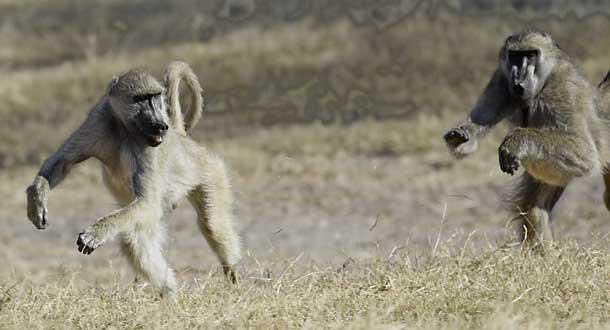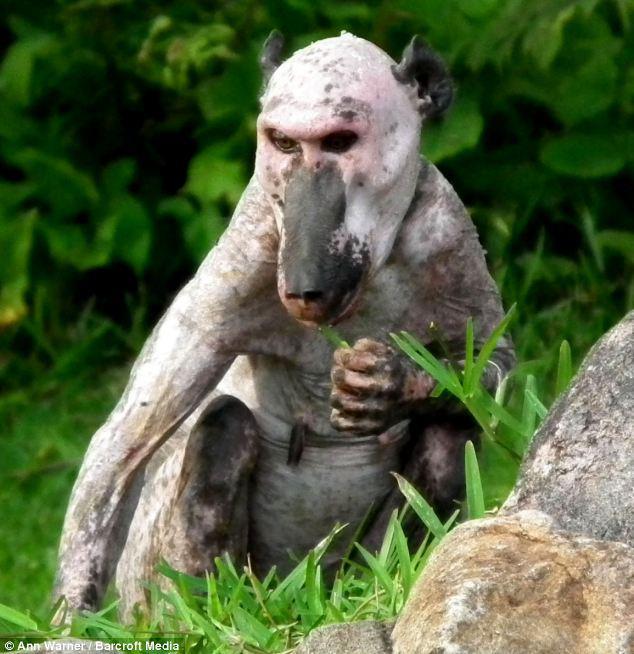The first image is the image on the left, the second image is the image on the right. For the images displayed, is the sentence "An image shows exactly one baboon, which is walking on all fours on the ground." factually correct? Answer yes or no. No. The first image is the image on the left, the second image is the image on the right. Given the left and right images, does the statement "There are at least two monkeys in the image on the right." hold true? Answer yes or no. No. 